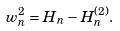<formula> <loc_0><loc_0><loc_500><loc_500>w _ { n } ^ { 2 } = H _ { n } - H _ { n } ^ { ( 2 ) } .</formula> 